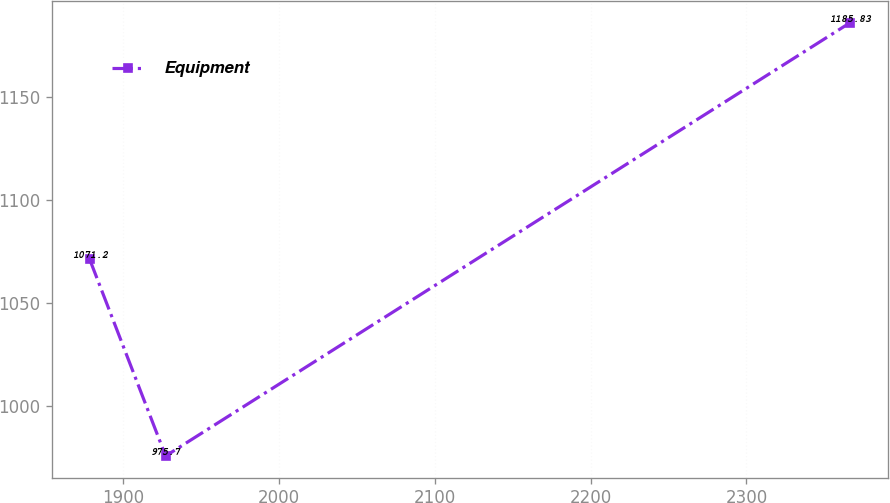Convert chart. <chart><loc_0><loc_0><loc_500><loc_500><line_chart><ecel><fcel>Equipment<nl><fcel>1878.75<fcel>1071.2<nl><fcel>1927.48<fcel>975.7<nl><fcel>2366.08<fcel>1185.83<nl></chart> 